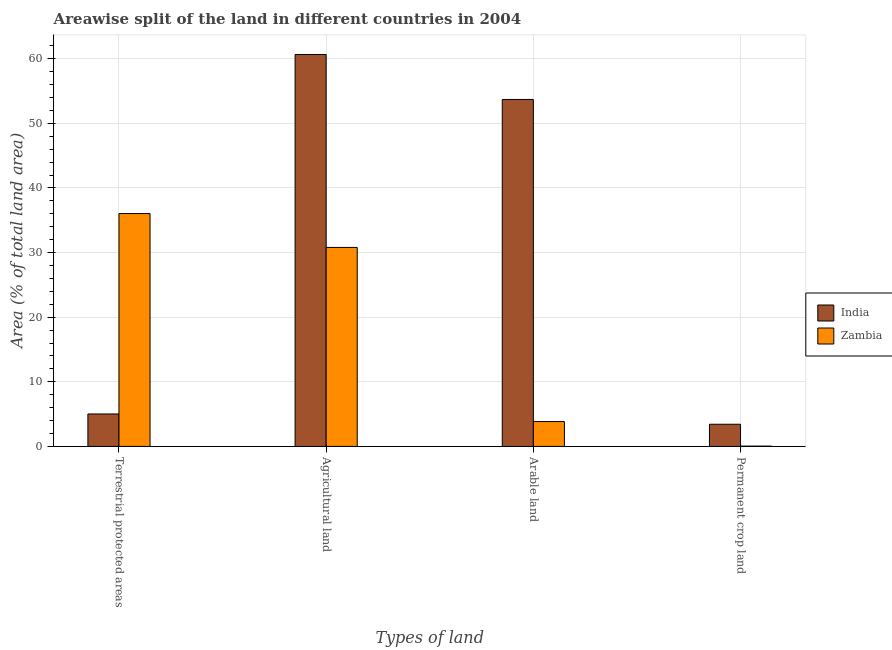How many groups of bars are there?
Your answer should be very brief. 4. Are the number of bars per tick equal to the number of legend labels?
Make the answer very short. Yes. Are the number of bars on each tick of the X-axis equal?
Offer a terse response. Yes. How many bars are there on the 4th tick from the left?
Give a very brief answer. 2. How many bars are there on the 2nd tick from the right?
Offer a terse response. 2. What is the label of the 4th group of bars from the left?
Your response must be concise. Permanent crop land. What is the percentage of area under permanent crop land in Zambia?
Offer a terse response. 0.05. Across all countries, what is the maximum percentage of area under arable land?
Your response must be concise. 53.71. Across all countries, what is the minimum percentage of land under terrestrial protection?
Give a very brief answer. 5.03. In which country was the percentage of area under arable land maximum?
Offer a terse response. India. What is the total percentage of land under terrestrial protection in the graph?
Keep it short and to the point. 41.07. What is the difference between the percentage of area under agricultural land in Zambia and that in India?
Your answer should be very brief. -29.87. What is the difference between the percentage of land under terrestrial protection in India and the percentage of area under agricultural land in Zambia?
Your answer should be compact. -25.78. What is the average percentage of area under arable land per country?
Your response must be concise. 28.78. What is the difference between the percentage of area under permanent crop land and percentage of area under agricultural land in Zambia?
Offer a very short reply. -30.75. In how many countries, is the percentage of area under permanent crop land greater than 34 %?
Ensure brevity in your answer.  0. What is the ratio of the percentage of land under terrestrial protection in Zambia to that in India?
Make the answer very short. 7.17. Is the percentage of area under agricultural land in Zambia less than that in India?
Make the answer very short. Yes. Is the difference between the percentage of area under permanent crop land in Zambia and India greater than the difference between the percentage of area under arable land in Zambia and India?
Offer a very short reply. Yes. What is the difference between the highest and the second highest percentage of land under terrestrial protection?
Provide a succinct answer. 31.02. What is the difference between the highest and the lowest percentage of area under permanent crop land?
Keep it short and to the point. 3.39. Is it the case that in every country, the sum of the percentage of area under permanent crop land and percentage of area under agricultural land is greater than the sum of percentage of land under terrestrial protection and percentage of area under arable land?
Your answer should be very brief. No. What does the 1st bar from the left in Permanent crop land represents?
Provide a short and direct response. India. What does the 2nd bar from the right in Arable land represents?
Keep it short and to the point. India. How many bars are there?
Provide a succinct answer. 8. How many countries are there in the graph?
Your answer should be compact. 2. Does the graph contain grids?
Your answer should be compact. Yes. How are the legend labels stacked?
Offer a terse response. Vertical. What is the title of the graph?
Offer a terse response. Areawise split of the land in different countries in 2004. What is the label or title of the X-axis?
Keep it short and to the point. Types of land. What is the label or title of the Y-axis?
Your response must be concise. Area (% of total land area). What is the Area (% of total land area) of India in Terrestrial protected areas?
Provide a short and direct response. 5.03. What is the Area (% of total land area) in Zambia in Terrestrial protected areas?
Offer a terse response. 36.04. What is the Area (% of total land area) of India in Agricultural land?
Provide a succinct answer. 60.67. What is the Area (% of total land area) in Zambia in Agricultural land?
Offer a very short reply. 30.8. What is the Area (% of total land area) of India in Arable land?
Your response must be concise. 53.71. What is the Area (% of total land area) in Zambia in Arable land?
Your response must be concise. 3.85. What is the Area (% of total land area) of India in Permanent crop land?
Your answer should be very brief. 3.43. What is the Area (% of total land area) in Zambia in Permanent crop land?
Ensure brevity in your answer.  0.05. Across all Types of land, what is the maximum Area (% of total land area) in India?
Provide a short and direct response. 60.67. Across all Types of land, what is the maximum Area (% of total land area) of Zambia?
Provide a short and direct response. 36.04. Across all Types of land, what is the minimum Area (% of total land area) of India?
Your answer should be compact. 3.43. Across all Types of land, what is the minimum Area (% of total land area) in Zambia?
Your answer should be very brief. 0.05. What is the total Area (% of total land area) of India in the graph?
Provide a short and direct response. 122.83. What is the total Area (% of total land area) of Zambia in the graph?
Give a very brief answer. 70.74. What is the difference between the Area (% of total land area) of India in Terrestrial protected areas and that in Agricultural land?
Your answer should be very brief. -55.64. What is the difference between the Area (% of total land area) of Zambia in Terrestrial protected areas and that in Agricultural land?
Ensure brevity in your answer.  5.24. What is the difference between the Area (% of total land area) of India in Terrestrial protected areas and that in Arable land?
Provide a succinct answer. -48.68. What is the difference between the Area (% of total land area) of Zambia in Terrestrial protected areas and that in Arable land?
Give a very brief answer. 32.19. What is the difference between the Area (% of total land area) in India in Terrestrial protected areas and that in Permanent crop land?
Make the answer very short. 1.59. What is the difference between the Area (% of total land area) of Zambia in Terrestrial protected areas and that in Permanent crop land?
Provide a short and direct response. 36. What is the difference between the Area (% of total land area) in India in Agricultural land and that in Arable land?
Offer a very short reply. 6.96. What is the difference between the Area (% of total land area) in Zambia in Agricultural land and that in Arable land?
Give a very brief answer. 26.95. What is the difference between the Area (% of total land area) of India in Agricultural land and that in Permanent crop land?
Offer a very short reply. 57.23. What is the difference between the Area (% of total land area) of Zambia in Agricultural land and that in Permanent crop land?
Make the answer very short. 30.75. What is the difference between the Area (% of total land area) in India in Arable land and that in Permanent crop land?
Offer a very short reply. 50.27. What is the difference between the Area (% of total land area) of Zambia in Arable land and that in Permanent crop land?
Provide a short and direct response. 3.8. What is the difference between the Area (% of total land area) of India in Terrestrial protected areas and the Area (% of total land area) of Zambia in Agricultural land?
Make the answer very short. -25.78. What is the difference between the Area (% of total land area) in India in Terrestrial protected areas and the Area (% of total land area) in Zambia in Arable land?
Your response must be concise. 1.18. What is the difference between the Area (% of total land area) in India in Terrestrial protected areas and the Area (% of total land area) in Zambia in Permanent crop land?
Your answer should be compact. 4.98. What is the difference between the Area (% of total land area) in India in Agricultural land and the Area (% of total land area) in Zambia in Arable land?
Ensure brevity in your answer.  56.82. What is the difference between the Area (% of total land area) in India in Agricultural land and the Area (% of total land area) in Zambia in Permanent crop land?
Offer a terse response. 60.62. What is the difference between the Area (% of total land area) in India in Arable land and the Area (% of total land area) in Zambia in Permanent crop land?
Make the answer very short. 53.66. What is the average Area (% of total land area) of India per Types of land?
Make the answer very short. 30.71. What is the average Area (% of total land area) of Zambia per Types of land?
Offer a terse response. 17.69. What is the difference between the Area (% of total land area) of India and Area (% of total land area) of Zambia in Terrestrial protected areas?
Your answer should be very brief. -31.02. What is the difference between the Area (% of total land area) of India and Area (% of total land area) of Zambia in Agricultural land?
Ensure brevity in your answer.  29.87. What is the difference between the Area (% of total land area) of India and Area (% of total land area) of Zambia in Arable land?
Your answer should be compact. 49.86. What is the difference between the Area (% of total land area) of India and Area (% of total land area) of Zambia in Permanent crop land?
Your response must be concise. 3.39. What is the ratio of the Area (% of total land area) of India in Terrestrial protected areas to that in Agricultural land?
Provide a succinct answer. 0.08. What is the ratio of the Area (% of total land area) in Zambia in Terrestrial protected areas to that in Agricultural land?
Your answer should be very brief. 1.17. What is the ratio of the Area (% of total land area) in India in Terrestrial protected areas to that in Arable land?
Give a very brief answer. 0.09. What is the ratio of the Area (% of total land area) in Zambia in Terrestrial protected areas to that in Arable land?
Ensure brevity in your answer.  9.36. What is the ratio of the Area (% of total land area) of India in Terrestrial protected areas to that in Permanent crop land?
Your answer should be very brief. 1.46. What is the ratio of the Area (% of total land area) of Zambia in Terrestrial protected areas to that in Permanent crop land?
Ensure brevity in your answer.  765.58. What is the ratio of the Area (% of total land area) in India in Agricultural land to that in Arable land?
Your answer should be very brief. 1.13. What is the ratio of the Area (% of total land area) of Zambia in Agricultural land to that in Arable land?
Your answer should be compact. 8. What is the ratio of the Area (% of total land area) in India in Agricultural land to that in Permanent crop land?
Your response must be concise. 17.67. What is the ratio of the Area (% of total land area) of Zambia in Agricultural land to that in Permanent crop land?
Provide a succinct answer. 654.2. What is the ratio of the Area (% of total land area) of India in Arable land to that in Permanent crop land?
Ensure brevity in your answer.  15.64. What is the ratio of the Area (% of total land area) in Zambia in Arable land to that in Permanent crop land?
Your answer should be very brief. 81.77. What is the difference between the highest and the second highest Area (% of total land area) of India?
Your answer should be compact. 6.96. What is the difference between the highest and the second highest Area (% of total land area) of Zambia?
Your answer should be compact. 5.24. What is the difference between the highest and the lowest Area (% of total land area) of India?
Your answer should be compact. 57.23. What is the difference between the highest and the lowest Area (% of total land area) of Zambia?
Make the answer very short. 36. 